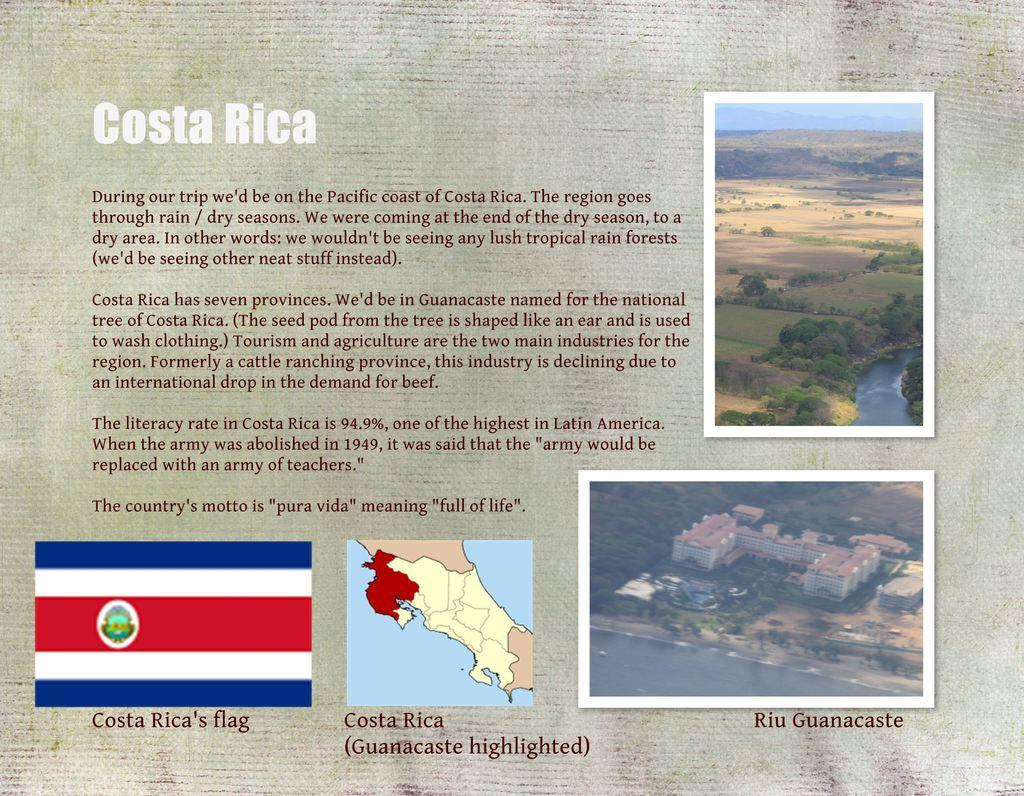What is the main subject of the poster in the image? The main subject of the poster in the image is Costa Rica. How is Costa Rica represented on the poster? The poster has the text "Costa Rica" written on it, and there are pictures of places and maps on the poster. What other symbol is present on the poster? There is a flag on the poster. How many tomatoes are on the poster in the image? There are no tomatoes present on the poster in the image. Can you describe the action of turning in the image? There is no action of turning depicted in the image. 